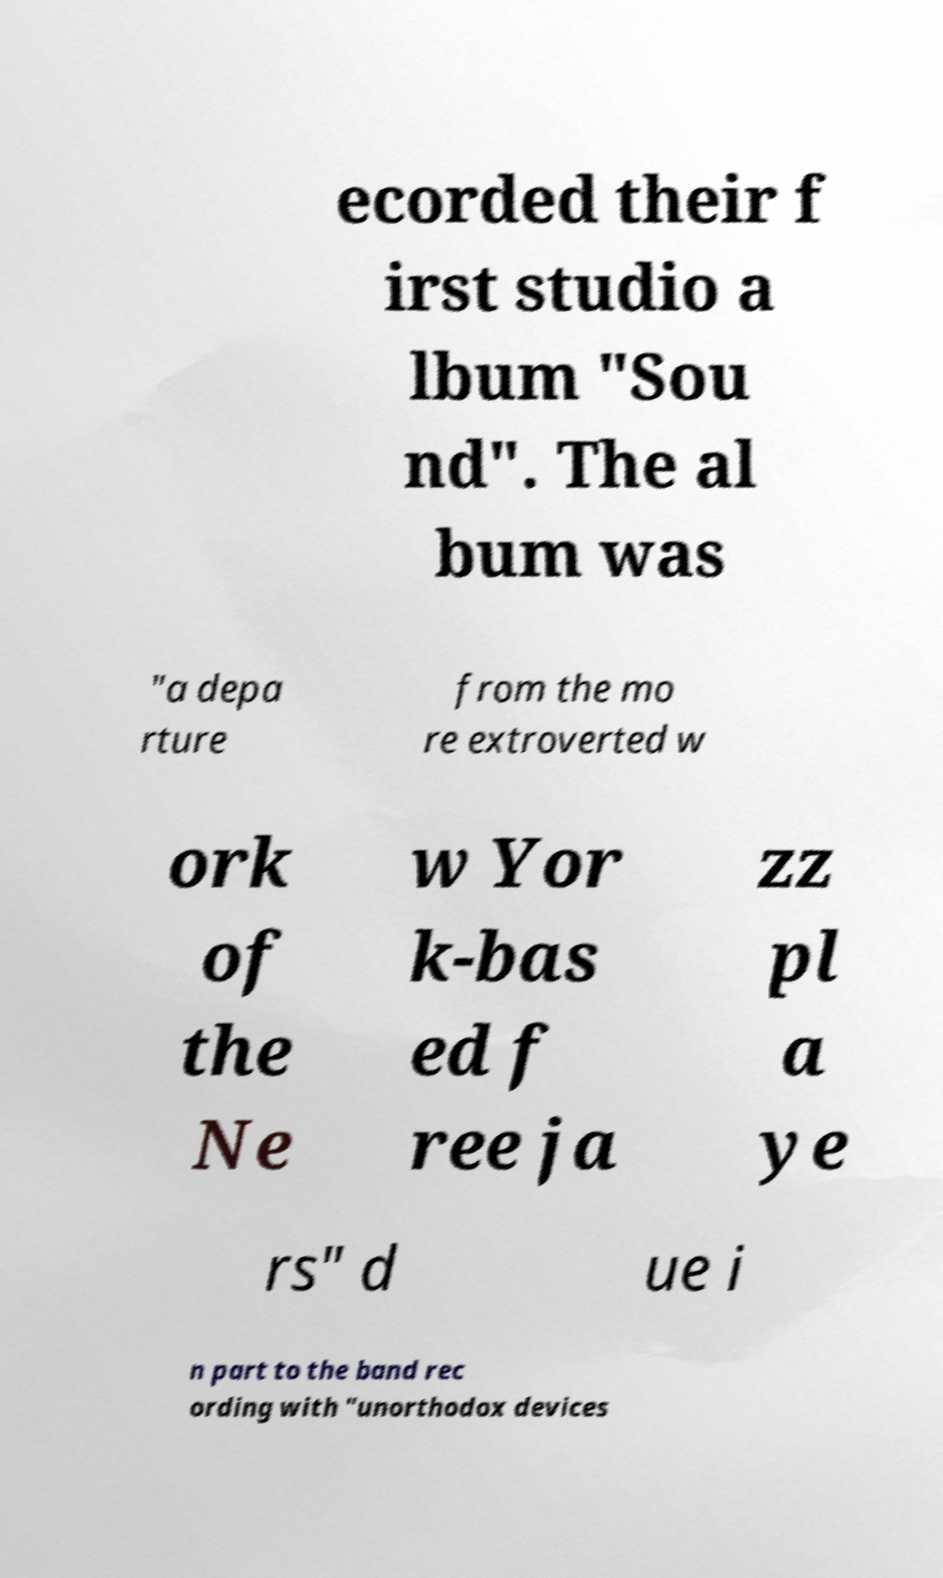I need the written content from this picture converted into text. Can you do that? ecorded their f irst studio a lbum "Sou nd". The al bum was "a depa rture from the mo re extroverted w ork of the Ne w Yor k-bas ed f ree ja zz pl a ye rs" d ue i n part to the band rec ording with "unorthodox devices 